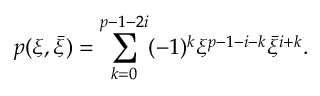Convert formula to latex. <formula><loc_0><loc_0><loc_500><loc_500>p ( \xi , \bar { \xi } ) = \sum _ { k = 0 } ^ { p - 1 - 2 i } ( - 1 ) ^ { k } \xi ^ { p - 1 - i - k } \bar { \xi } ^ { i + k } .</formula> 